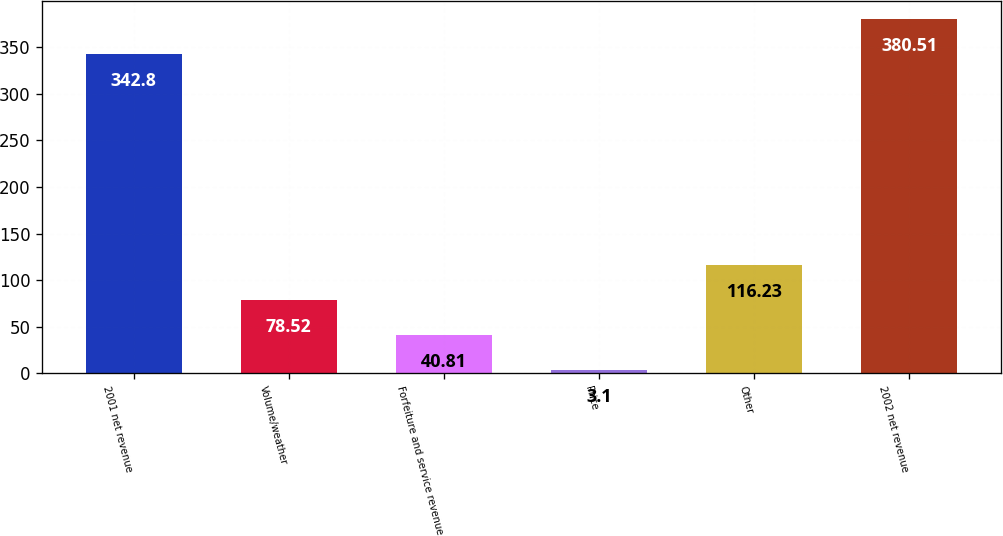Convert chart to OTSL. <chart><loc_0><loc_0><loc_500><loc_500><bar_chart><fcel>2001 net revenue<fcel>Volume/weather<fcel>Forfeiture and service revenue<fcel>Price<fcel>Other<fcel>2002 net revenue<nl><fcel>342.8<fcel>78.52<fcel>40.81<fcel>3.1<fcel>116.23<fcel>380.51<nl></chart> 